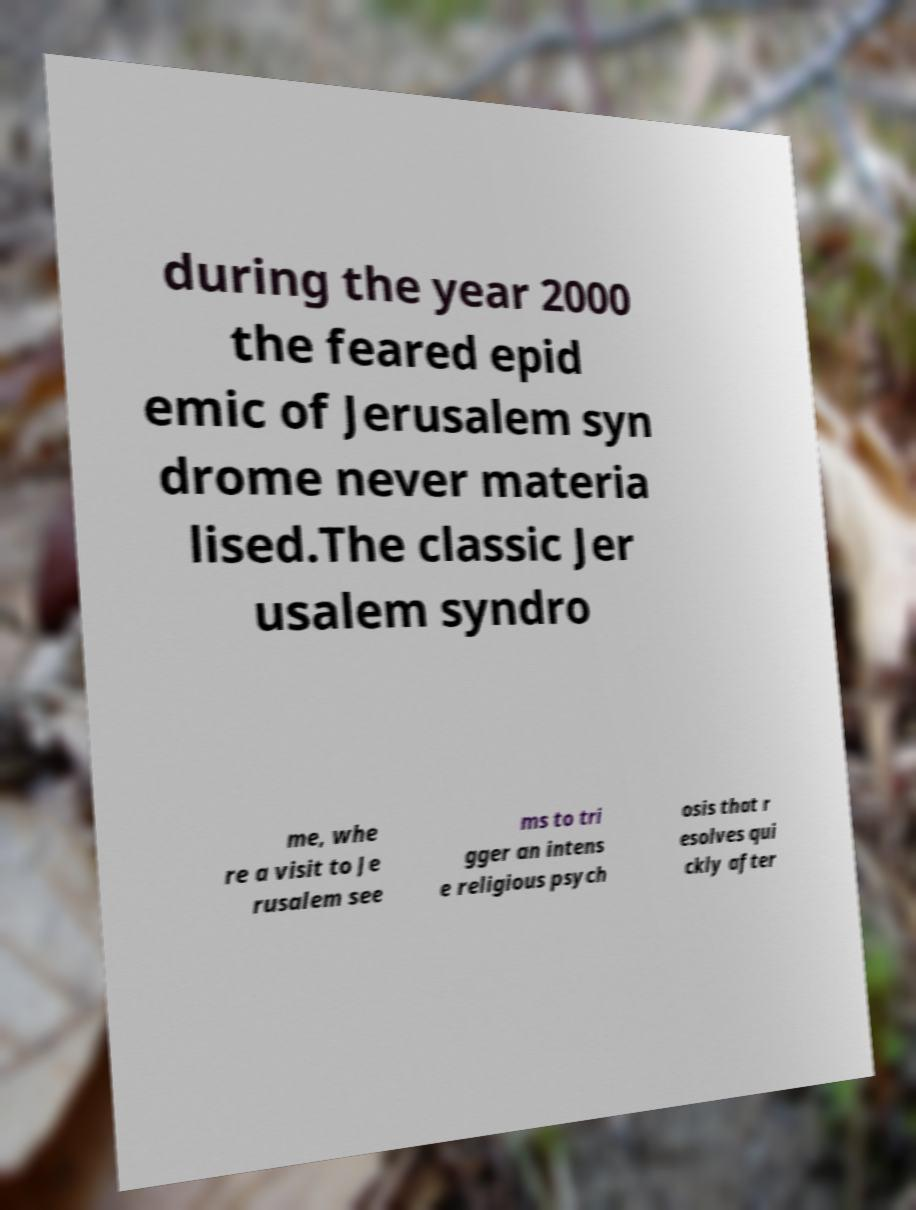There's text embedded in this image that I need extracted. Can you transcribe it verbatim? during the year 2000 the feared epid emic of Jerusalem syn drome never materia lised.The classic Jer usalem syndro me, whe re a visit to Je rusalem see ms to tri gger an intens e religious psych osis that r esolves qui ckly after 